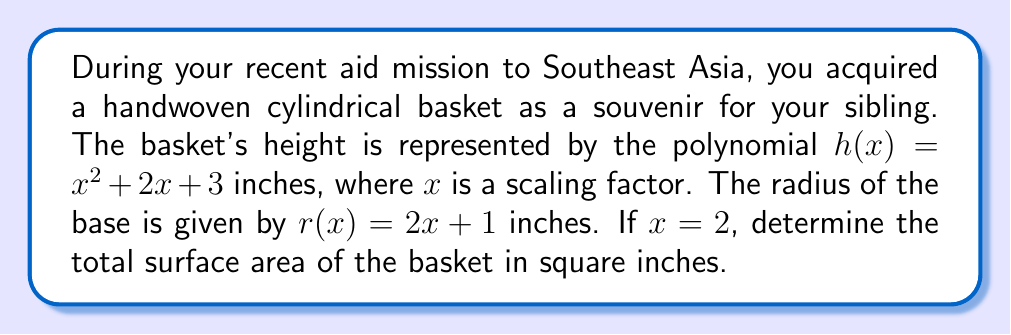Show me your answer to this math problem. Let's approach this step-by-step:

1) First, we need to calculate the height and radius when $x = 2$:

   Height: $h(2) = 2^2 + 2(2) + 3 = 4 + 4 + 3 = 11$ inches
   Radius: $r(2) = 2(2) + 1 = 4 + 1 = 5$ inches

2) The surface area of a cylinder consists of two circular bases and the lateral surface:

   $SA = 2\pi r^2 + 2\pi rh$

3) Let's substitute our values:

   $SA = 2\pi (5^2) + 2\pi (5)(11)$

4) Simplify:

   $SA = 2\pi (25) + 2\pi (55)$
   $SA = 50\pi + 110\pi$
   $SA = 160\pi$

5) If we want to express this as a decimal, we can multiply by $\pi$:

   $SA \approx 160 \cdot 3.14159 \approx 502.65$ square inches
Answer: $160\pi$ or approximately 502.65 square inches 